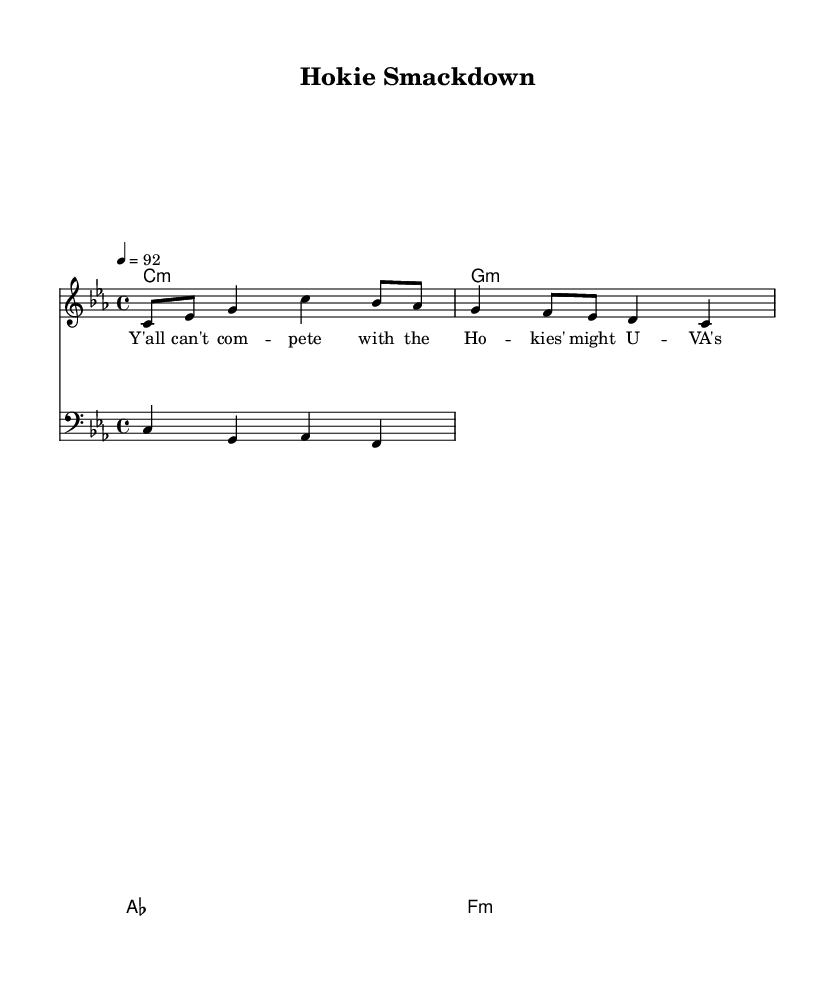What is the key signature of this music? The key signature is C minor, which contains three flat notes: B flat, E flat, and A flat. This can be identified from the indicated key signature at the beginning of the staff.
Answer: C minor What is the time signature of this music? The time signature is 4/4, which means there are four beats in a measure and the quarter note gets one beat. This is seen on the left side of the staff at the beginning of the piece.
Answer: 4/4 What is the tempo marking of this music? The tempo marking is 92 beats per minute, indicated by the "4 = 92" notation at the beginning, specifying the speed at which the music should be played.
Answer: 92 How many measures are in the melody? There are four measures in the melody, as counted by the number of vertical lines partitioning the music into segments. Each segment indicates a measure.
Answer: 4 Which college football team is being dissed in the lyrics? The lyrics specifically mention "U-VA," which is a reference to the University of Virginia, indicating that they are the rival team being dissed. This is part of the verse labeled in the music.
Answer: U-VA What overall mood does the song convey? The song conveys a confident and mocking mood directed towards rival fans, as indicated by the lyrics' aggressive tone and choice of words like "can't compete" and "just a joke." This captures the competitive nature of college football rivalries.
Answer: Confident and mocking 